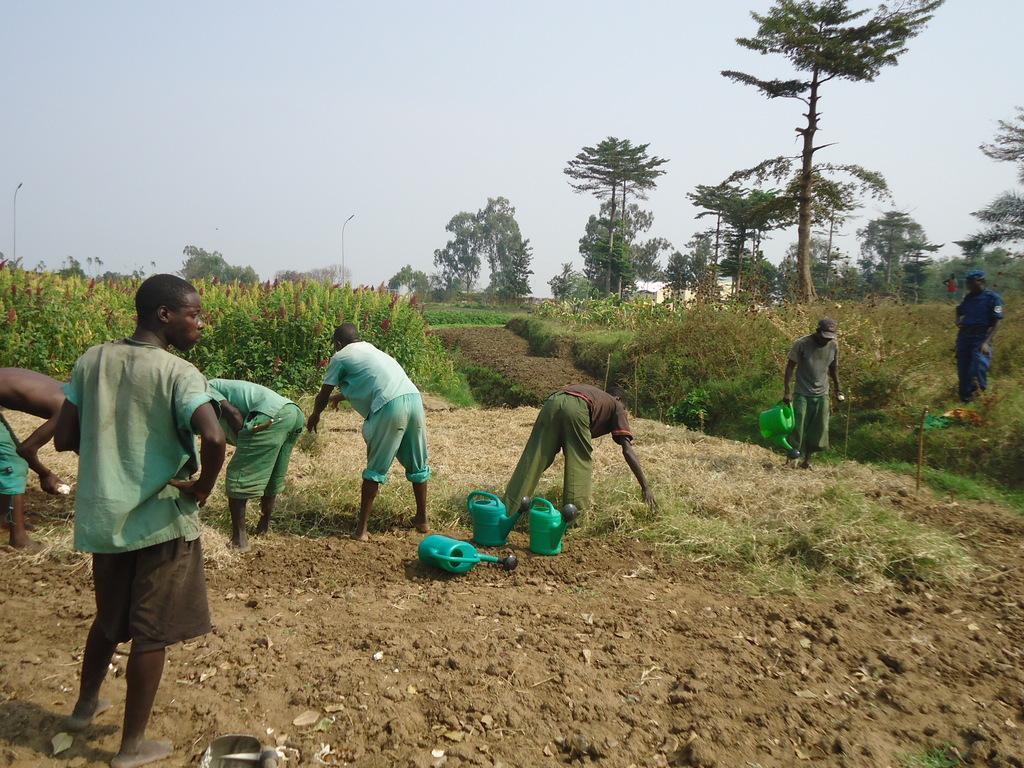In one or two sentences, can you explain what this image depicts? There are people,this man standing and this person holding a water can. We can see water cans on the surface and grass. Background we can see trees,plants and sky. 